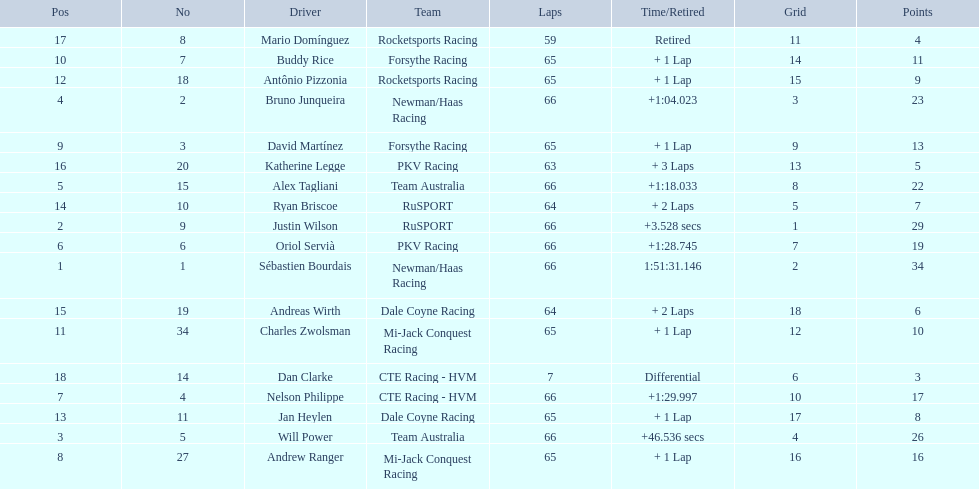Which drivers scored at least 10 points? Sébastien Bourdais, Justin Wilson, Will Power, Bruno Junqueira, Alex Tagliani, Oriol Servià, Nelson Philippe, Andrew Ranger, David Martínez, Buddy Rice, Charles Zwolsman. Of those drivers, which ones scored at least 20 points? Sébastien Bourdais, Justin Wilson, Will Power, Bruno Junqueira, Alex Tagliani. Of those 5, which driver scored the most points? Sébastien Bourdais. 